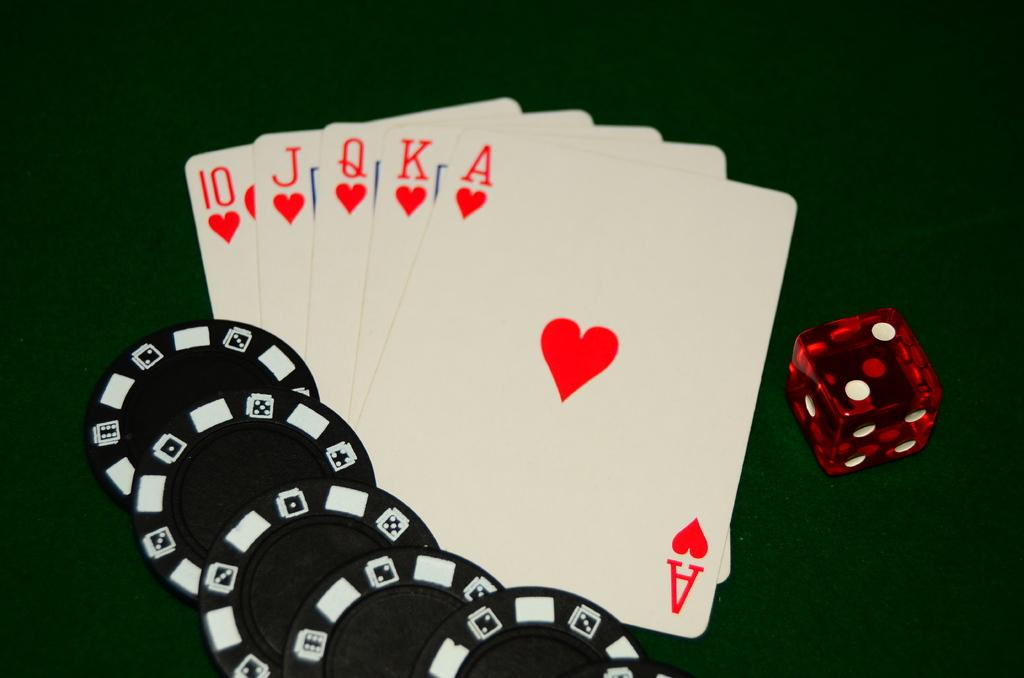<image>
Create a compact narrative representing the image presented. A few cards laying together with a die and some poker chips on the opposite sides of the cards and the cards have an ace among them. 